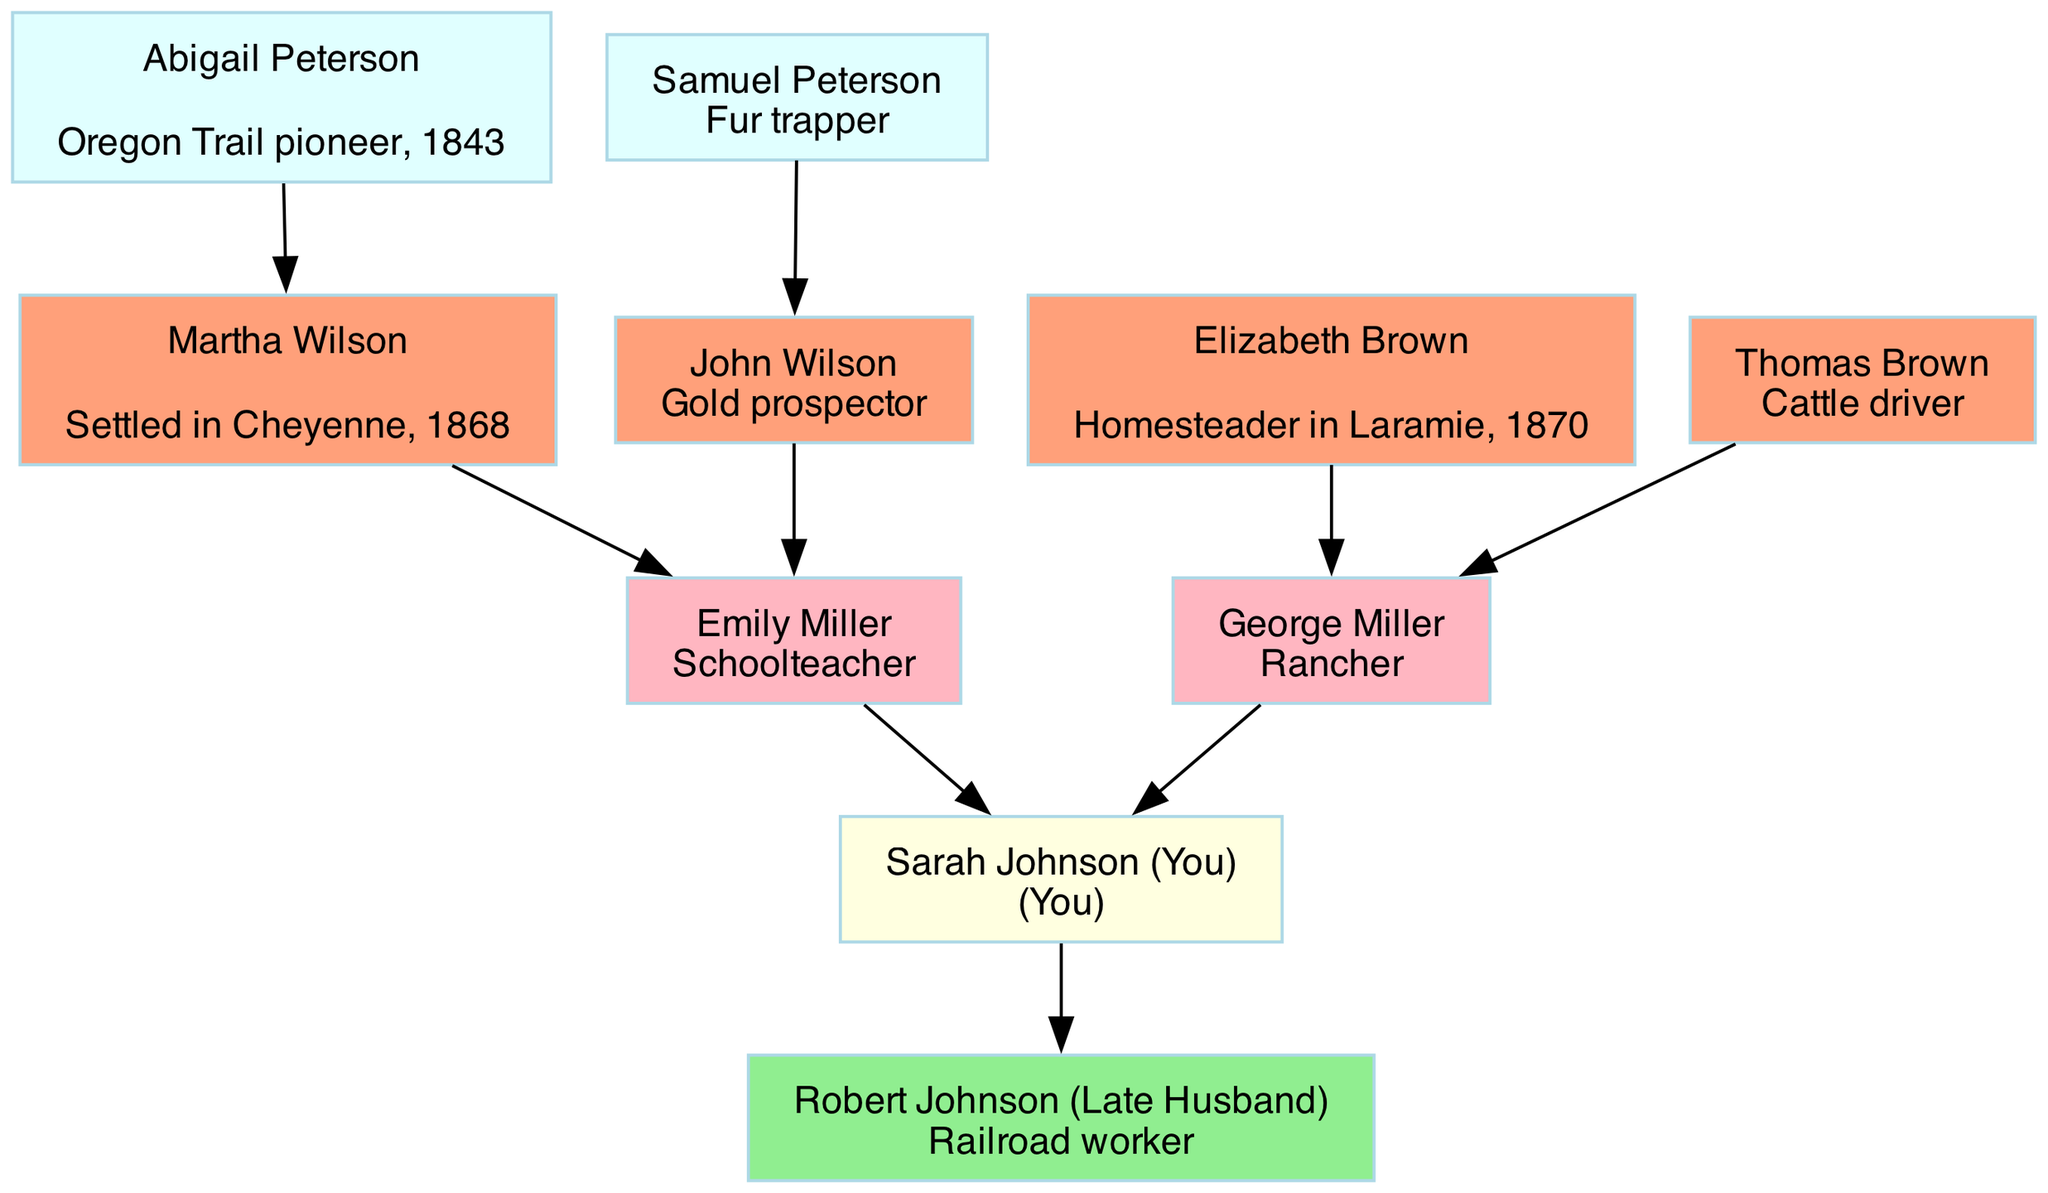What is the occupation of Robert Johnson? Robert Johnson is listed as a railroad worker in the diagram, which is stated next to his name.
Answer: railroad worker How many grandparents are depicted in the family tree? There are four grandparents shown, as indicated by the connections leading to the parents. Each grandparent is represented as a node.
Answer: 4 Who is the great-grandparent known as a pioneer from the Oregon Trail? Abigail Peterson is mentioned in the family tree as the Oregon Trail pioneer, with the note stating her year of pioneering.
Answer: Abigail Peterson What relationship does George Miller have to Sarah Johnson? George Miller is Sarah Johnson's father, as he is included in the list of parents connected directly to her.
Answer: father Which ancestor settled in Cheyenne in 1868? Martha Wilson is shown to have settled in Cheyenne in 1868, as noted in her description in the family tree.
Answer: Martha Wilson How is Emily Miller related to John Wilson? Emily Miller is the daughter of John Wilson as she is the child linked to him among the grandparents in the tree structure.
Answer: granddaughter What is the occupation of Thomas Brown? Thomas Brown is listed as a cattle driver in the family tree, which is part of his node's information.
Answer: Cattle driver Which ancestor appears twice in the diagram, once in the grandparents section and once in the parents section? None of the ancestors repeat in the diagram; each ancestor has a unique position, either as grandparents or parents as shown, with no duplications.
Answer: None How many nodes represent great-grandparents in the tree? There are two nodes representing great-grandparents, as indicated directly by their two entries under the great-grandparents section.
Answer: 2 